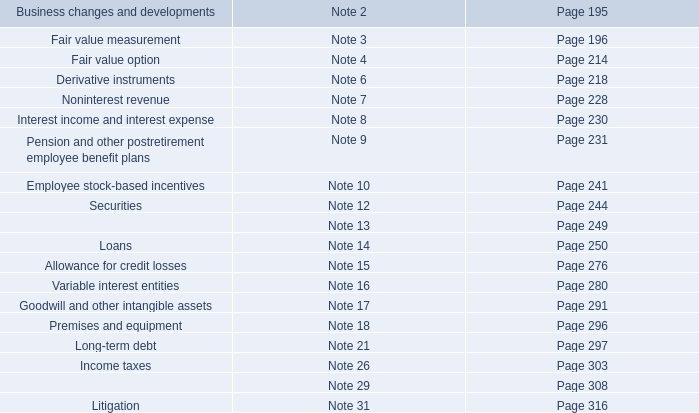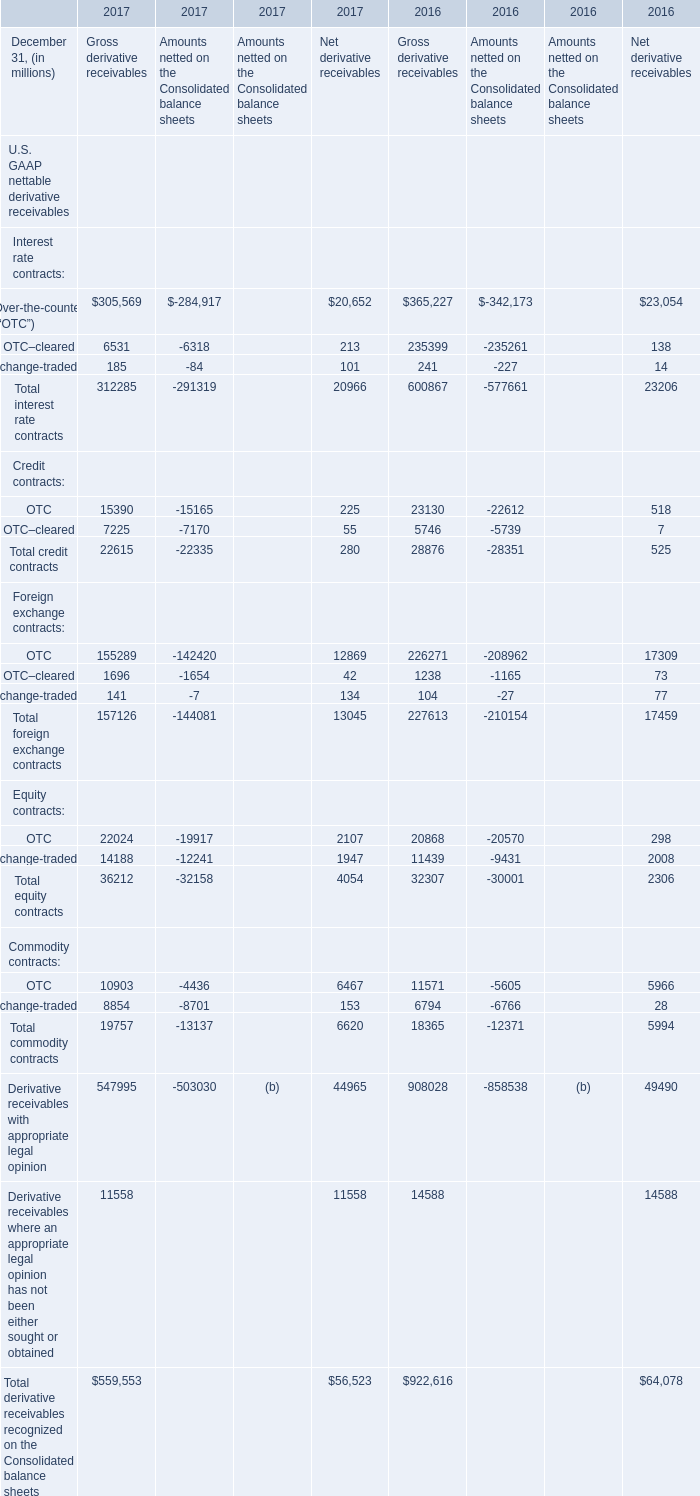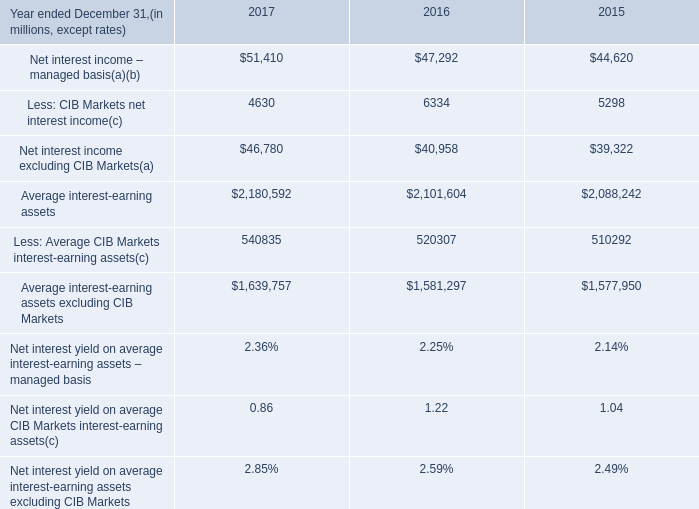In the year with largest amount of Gross derivative receivables, what's the increasing rate of Over-the-counter (“OTC”) for Gross derivative receivables? 
Computations: ((305569 - 365227) / 365227)
Answer: -0.16334. Which year is Exchange-traded(a) for Gross derivative receivables the highest? 
Answer: 2016. 